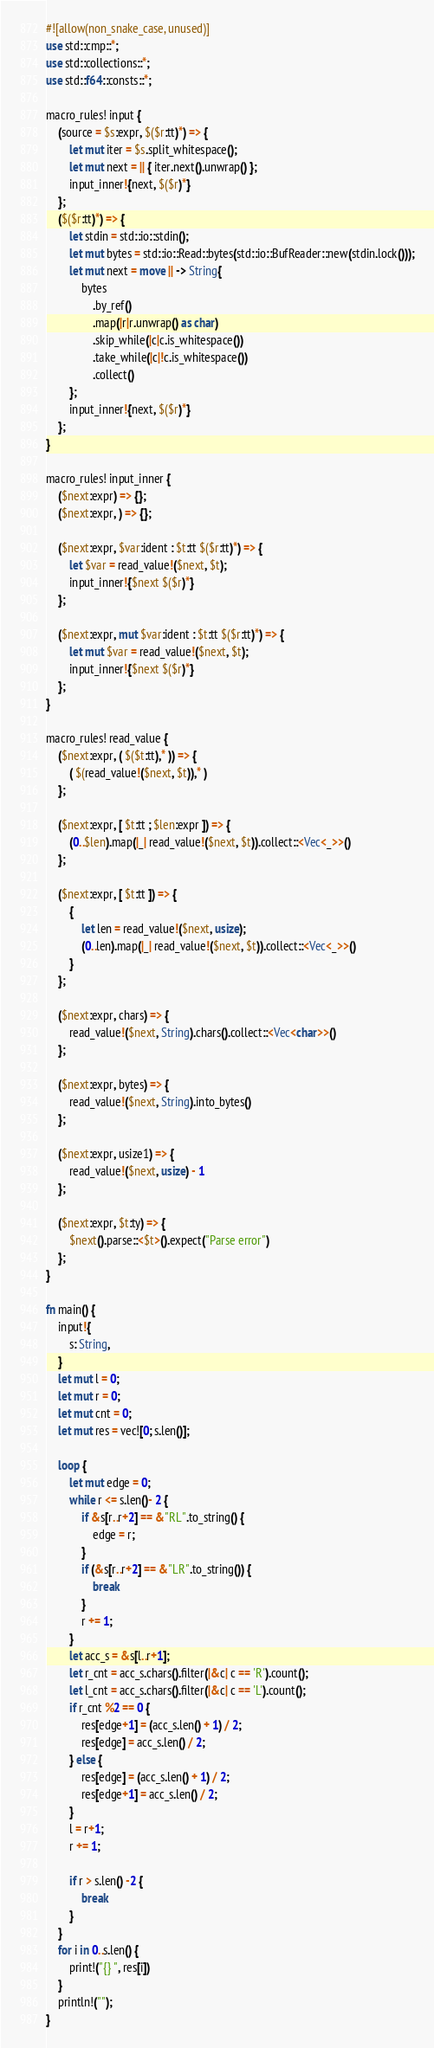<code> <loc_0><loc_0><loc_500><loc_500><_Rust_>#![allow(non_snake_case, unused)]
use std::cmp::*;
use std::collections::*;
use std::f64::consts::*;

macro_rules! input {
    (source = $s:expr, $($r:tt)*) => {
        let mut iter = $s.split_whitespace();
        let mut next = || { iter.next().unwrap() };
        input_inner!{next, $($r)*}
    };
    ($($r:tt)*) => {
        let stdin = std::io::stdin();
        let mut bytes = std::io::Read::bytes(std::io::BufReader::new(stdin.lock()));
        let mut next = move || -> String{
            bytes
                .by_ref()
                .map(|r|r.unwrap() as char)
                .skip_while(|c|c.is_whitespace())
                .take_while(|c|!c.is_whitespace())
                .collect()
        };
        input_inner!{next, $($r)*}
    };
}

macro_rules! input_inner {
    ($next:expr) => {};
    ($next:expr, ) => {};

    ($next:expr, $var:ident : $t:tt $($r:tt)*) => {
        let $var = read_value!($next, $t);
        input_inner!{$next $($r)*}
    };

    ($next:expr, mut $var:ident : $t:tt $($r:tt)*) => {
        let mut $var = read_value!($next, $t);
        input_inner!{$next $($r)*}
    };
}

macro_rules! read_value {
    ($next:expr, ( $($t:tt),* )) => {
        ( $(read_value!($next, $t)),* )
    };

    ($next:expr, [ $t:tt ; $len:expr ]) => {
        (0..$len).map(|_| read_value!($next, $t)).collect::<Vec<_>>()
    };

    ($next:expr, [ $t:tt ]) => {
        {
            let len = read_value!($next, usize);
            (0..len).map(|_| read_value!($next, $t)).collect::<Vec<_>>()
        }
    };

    ($next:expr, chars) => {
        read_value!($next, String).chars().collect::<Vec<char>>()
    };

    ($next:expr, bytes) => {
        read_value!($next, String).into_bytes()
    };

    ($next:expr, usize1) => {
        read_value!($next, usize) - 1
    };

    ($next:expr, $t:ty) => {
        $next().parse::<$t>().expect("Parse error")
    };
}

fn main() {
    input!{
        s: String,
    }
    let mut l = 0;
    let mut r = 0;
    let mut cnt = 0;
    let mut res = vec![0; s.len()];

    loop {
        let mut edge = 0;
        while r <= s.len()- 2 {
            if &s[r..r+2] == &"RL".to_string() {
                edge = r;
            }
            if (&s[r..r+2] == &"LR".to_string()) {
                break
            }
            r += 1;
        }
        let acc_s = &s[l..r+1];
        let r_cnt = acc_s.chars().filter(|&c| c == 'R').count();
        let l_cnt = acc_s.chars().filter(|&c| c == 'L').count();
        if r_cnt %2 == 0 {
            res[edge+1] = (acc_s.len() + 1) / 2;
            res[edge] = acc_s.len() / 2;
        } else {
            res[edge] = (acc_s.len() + 1) / 2;
            res[edge+1] = acc_s.len() / 2;
        }
        l = r+1;
        r += 1;

        if r > s.len() -2 {
            break
        } 
    }
    for i in 0..s.len() {
        print!("{} ", res[i])
    }
    println!("");
}
</code> 